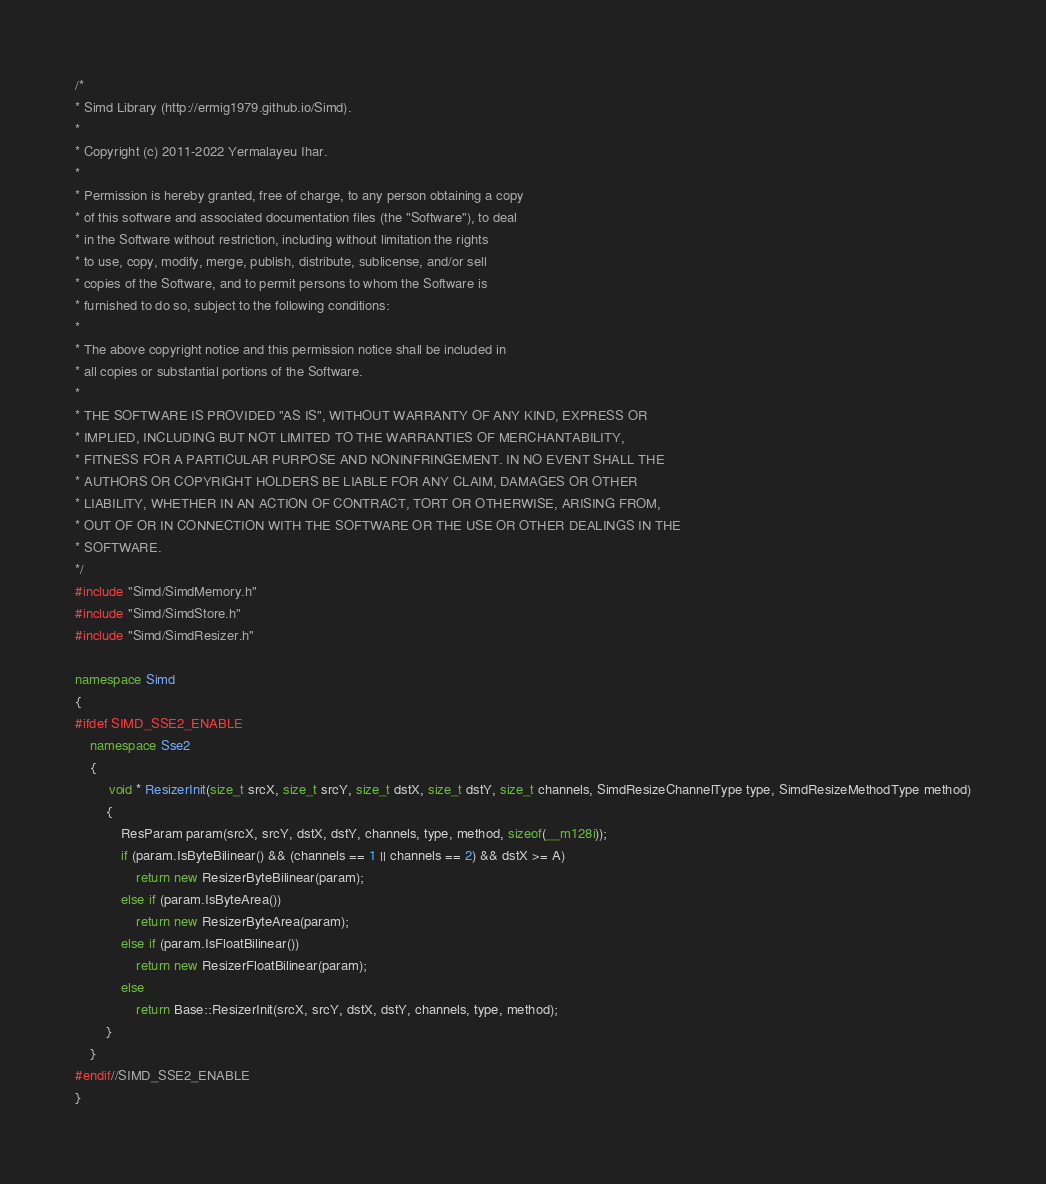<code> <loc_0><loc_0><loc_500><loc_500><_C++_>/*
* Simd Library (http://ermig1979.github.io/Simd).
*
* Copyright (c) 2011-2022 Yermalayeu Ihar.
*
* Permission is hereby granted, free of charge, to any person obtaining a copy
* of this software and associated documentation files (the "Software"), to deal
* in the Software without restriction, including without limitation the rights
* to use, copy, modify, merge, publish, distribute, sublicense, and/or sell
* copies of the Software, and to permit persons to whom the Software is
* furnished to do so, subject to the following conditions:
*
* The above copyright notice and this permission notice shall be included in
* all copies or substantial portions of the Software.
*
* THE SOFTWARE IS PROVIDED "AS IS", WITHOUT WARRANTY OF ANY KIND, EXPRESS OR
* IMPLIED, INCLUDING BUT NOT LIMITED TO THE WARRANTIES OF MERCHANTABILITY,
* FITNESS FOR A PARTICULAR PURPOSE AND NONINFRINGEMENT. IN NO EVENT SHALL THE
* AUTHORS OR COPYRIGHT HOLDERS BE LIABLE FOR ANY CLAIM, DAMAGES OR OTHER
* LIABILITY, WHETHER IN AN ACTION OF CONTRACT, TORT OR OTHERWISE, ARISING FROM,
* OUT OF OR IN CONNECTION WITH THE SOFTWARE OR THE USE OR OTHER DEALINGS IN THE
* SOFTWARE.
*/
#include "Simd/SimdMemory.h"
#include "Simd/SimdStore.h"
#include "Simd/SimdResizer.h"

namespace Simd
{
#ifdef SIMD_SSE2_ENABLE
    namespace Sse2
    {
         void * ResizerInit(size_t srcX, size_t srcY, size_t dstX, size_t dstY, size_t channels, SimdResizeChannelType type, SimdResizeMethodType method)
        {
            ResParam param(srcX, srcY, dstX, dstY, channels, type, method, sizeof(__m128i));
            if (param.IsByteBilinear() && (channels == 1 || channels == 2) && dstX >= A)
                return new ResizerByteBilinear(param);
            else if (param.IsByteArea())
                return new ResizerByteArea(param);
            else if (param.IsFloatBilinear())
                return new ResizerFloatBilinear(param);
            else
                return Base::ResizerInit(srcX, srcY, dstX, dstY, channels, type, method);
        }
    }
#endif//SIMD_SSE2_ENABLE
}

</code> 